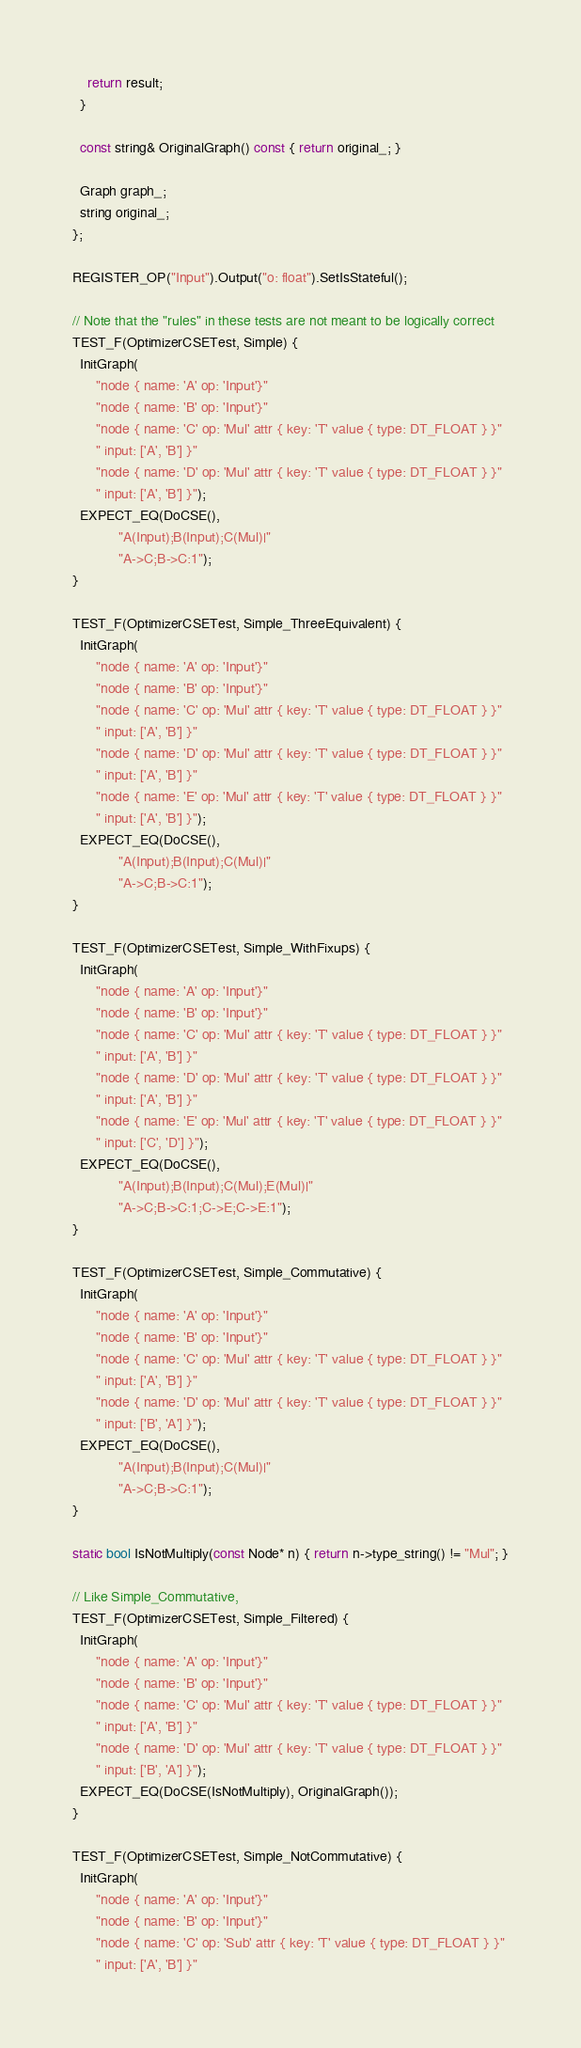<code> <loc_0><loc_0><loc_500><loc_500><_C++_>    return result;
  }

  const string& OriginalGraph() const { return original_; }

  Graph graph_;
  string original_;
};

REGISTER_OP("Input").Output("o: float").SetIsStateful();

// Note that the "rules" in these tests are not meant to be logically correct
TEST_F(OptimizerCSETest, Simple) {
  InitGraph(
      "node { name: 'A' op: 'Input'}"
      "node { name: 'B' op: 'Input'}"
      "node { name: 'C' op: 'Mul' attr { key: 'T' value { type: DT_FLOAT } }"
      " input: ['A', 'B'] }"
      "node { name: 'D' op: 'Mul' attr { key: 'T' value { type: DT_FLOAT } }"
      " input: ['A', 'B'] }");
  EXPECT_EQ(DoCSE(),
            "A(Input);B(Input);C(Mul)|"
            "A->C;B->C:1");
}

TEST_F(OptimizerCSETest, Simple_ThreeEquivalent) {
  InitGraph(
      "node { name: 'A' op: 'Input'}"
      "node { name: 'B' op: 'Input'}"
      "node { name: 'C' op: 'Mul' attr { key: 'T' value { type: DT_FLOAT } }"
      " input: ['A', 'B'] }"
      "node { name: 'D' op: 'Mul' attr { key: 'T' value { type: DT_FLOAT } }"
      " input: ['A', 'B'] }"
      "node { name: 'E' op: 'Mul' attr { key: 'T' value { type: DT_FLOAT } }"
      " input: ['A', 'B'] }");
  EXPECT_EQ(DoCSE(),
            "A(Input);B(Input);C(Mul)|"
            "A->C;B->C:1");
}

TEST_F(OptimizerCSETest, Simple_WithFixups) {
  InitGraph(
      "node { name: 'A' op: 'Input'}"
      "node { name: 'B' op: 'Input'}"
      "node { name: 'C' op: 'Mul' attr { key: 'T' value { type: DT_FLOAT } }"
      " input: ['A', 'B'] }"
      "node { name: 'D' op: 'Mul' attr { key: 'T' value { type: DT_FLOAT } }"
      " input: ['A', 'B'] }"
      "node { name: 'E' op: 'Mul' attr { key: 'T' value { type: DT_FLOAT } }"
      " input: ['C', 'D'] }");
  EXPECT_EQ(DoCSE(),
            "A(Input);B(Input);C(Mul);E(Mul)|"
            "A->C;B->C:1;C->E;C->E:1");
}

TEST_F(OptimizerCSETest, Simple_Commutative) {
  InitGraph(
      "node { name: 'A' op: 'Input'}"
      "node { name: 'B' op: 'Input'}"
      "node { name: 'C' op: 'Mul' attr { key: 'T' value { type: DT_FLOAT } }"
      " input: ['A', 'B'] }"
      "node { name: 'D' op: 'Mul' attr { key: 'T' value { type: DT_FLOAT } }"
      " input: ['B', 'A'] }");
  EXPECT_EQ(DoCSE(),
            "A(Input);B(Input);C(Mul)|"
            "A->C;B->C:1");
}

static bool IsNotMultiply(const Node* n) { return n->type_string() != "Mul"; }

// Like Simple_Commutative,
TEST_F(OptimizerCSETest, Simple_Filtered) {
  InitGraph(
      "node { name: 'A' op: 'Input'}"
      "node { name: 'B' op: 'Input'}"
      "node { name: 'C' op: 'Mul' attr { key: 'T' value { type: DT_FLOAT } }"
      " input: ['A', 'B'] }"
      "node { name: 'D' op: 'Mul' attr { key: 'T' value { type: DT_FLOAT } }"
      " input: ['B', 'A'] }");
  EXPECT_EQ(DoCSE(IsNotMultiply), OriginalGraph());
}

TEST_F(OptimizerCSETest, Simple_NotCommutative) {
  InitGraph(
      "node { name: 'A' op: 'Input'}"
      "node { name: 'B' op: 'Input'}"
      "node { name: 'C' op: 'Sub' attr { key: 'T' value { type: DT_FLOAT } }"
      " input: ['A', 'B'] }"</code> 